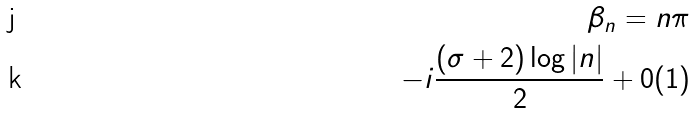Convert formula to latex. <formula><loc_0><loc_0><loc_500><loc_500>\beta _ { n } = n \pi \\ - i \frac { ( \sigma + 2 ) \log | n | } { 2 } + 0 ( 1 )</formula> 